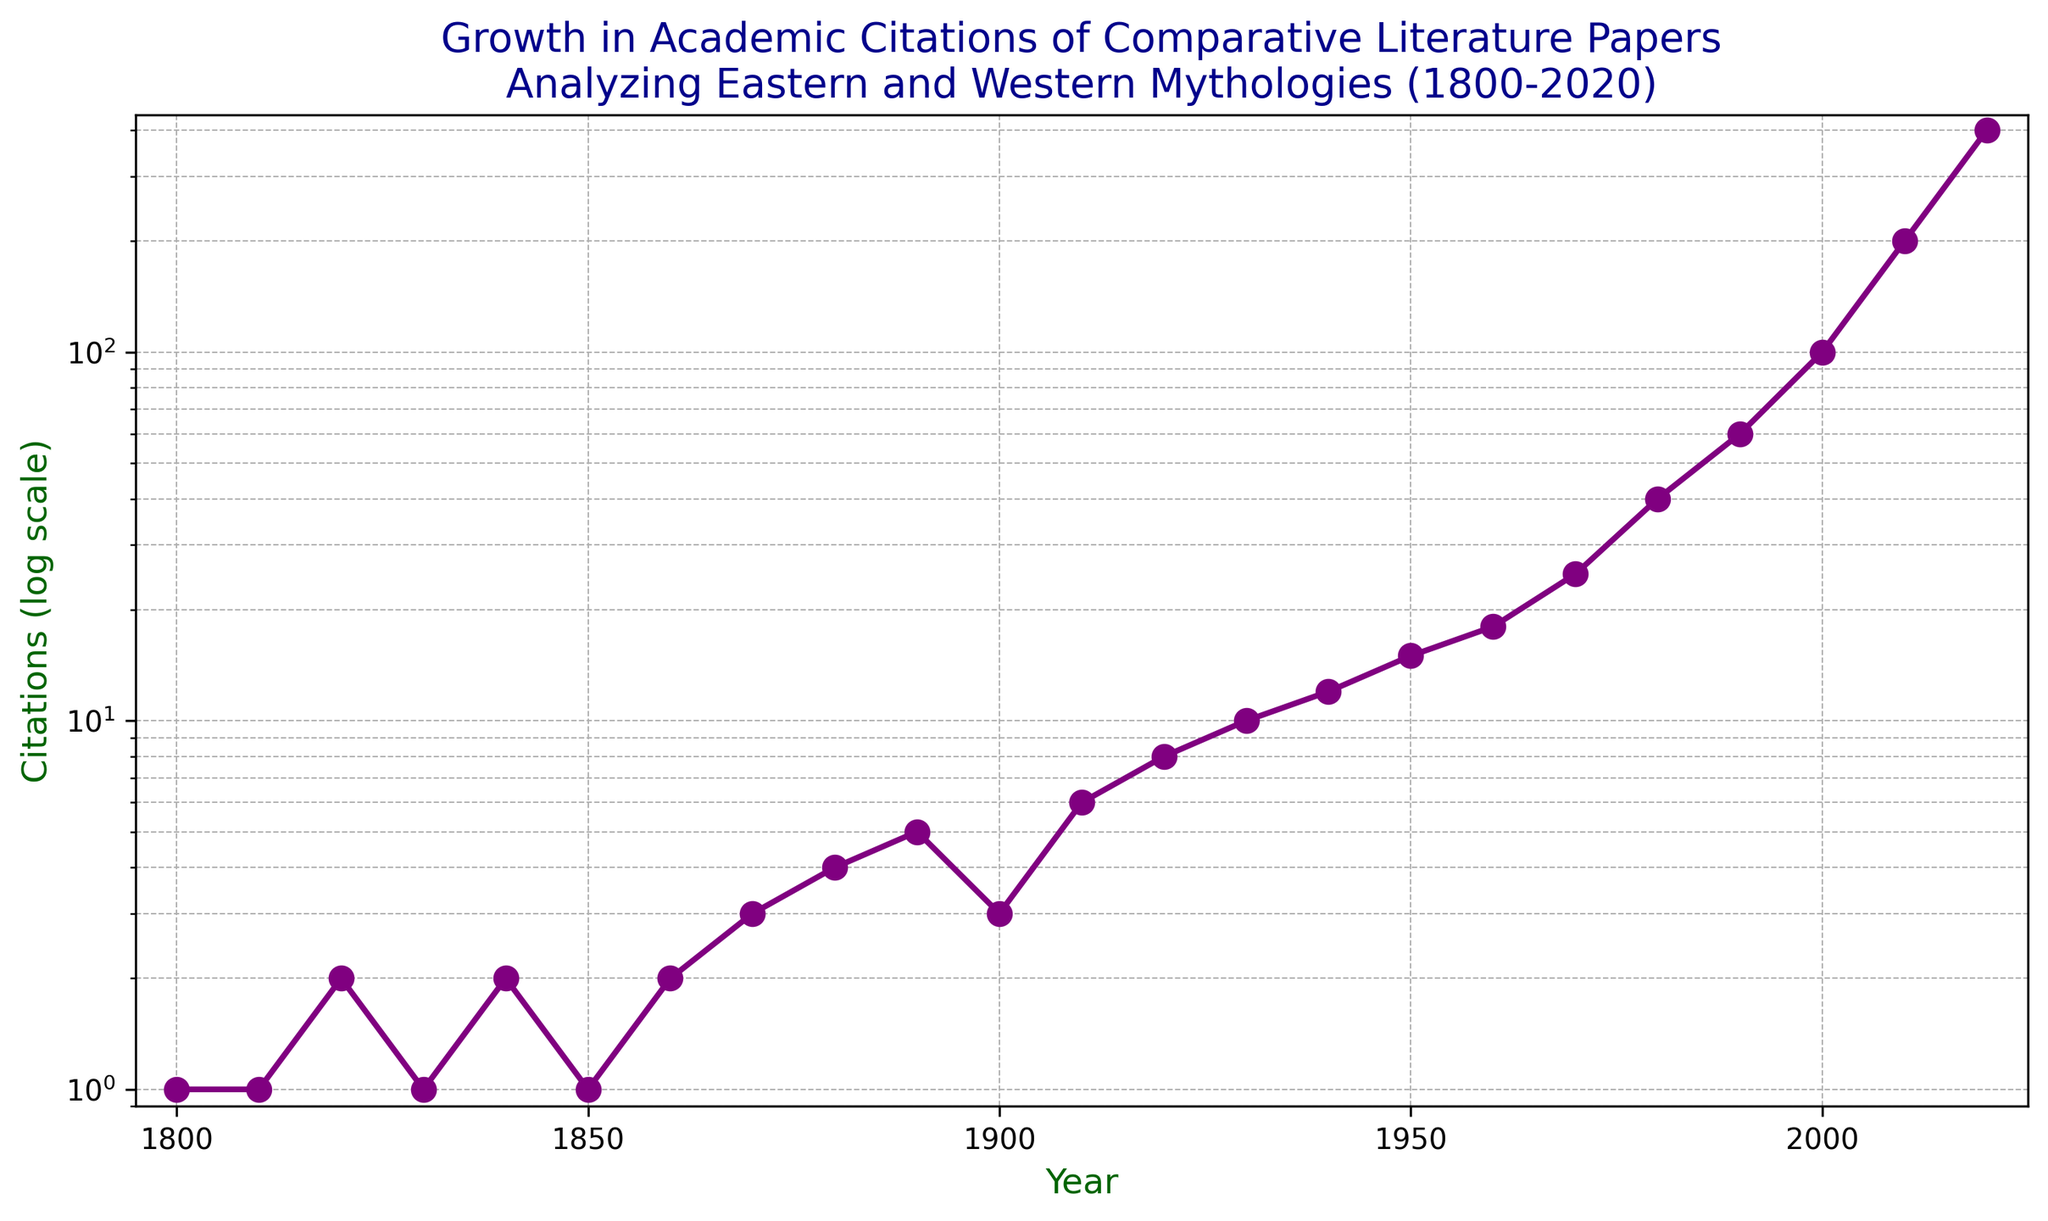What is the overall trend in the number of citations from 1800 to 2020? The citations exhibit a clear exponential growth trend. Starting with low citation counts in the 1800s, the numbers steadily increase over time, particularly accelerating after the 1970s. This exponential pattern is evidenced by the rapid rise from 100 citations in 2000 to 400 citations by 2020.
Answer: Exponential growth In which decade did the citations first reach double digits? By reviewing the data points on the chart, we see that citations first reached double digits in the 1930s, where the figure is indicated to be 10.
Answer: 1930s How many more citations were there in 2020 compared to 1970? Subtract the number of citations in 1970 from those in 2020: 400 - 25 = 375.
Answer: 375 How many times did the number of citations increase from 1900 to 2000? Compare the values for 1900 and 2000. The value in 1900 is 3 and in 2000 is 100. Divide 100 by 3 to find the increase factor: 100 / 3 ≈ 33.33 times.
Answer: ~33 times Which period had the most rapid increase in citations: 1900 to 1950 or 1950 to 2000? Calculate the increases for both periods: 1900 to 1950 increased from 3 to 15 (15 - 3 = 12), and 1950 to 2000 increased from 15 to 100 (100 - 15 = 85). Comparing the increases, the rapid increase occurred from 1950 to 2000.
Answer: 1950 to 2000 Are there any periods where the number of citations decreased or remained constant? Observing the data for any dips or plateaus, particularly between 1800-1890 and 1900-1910 do not show any clear decreases or prolonged constancy, indicating a generally consistent growth.
Answer: No In what year did the number of citations double from one decade to the next? Look for points on the graph where the values double. From 1980 to 1990, citations doubled from 40 to 60, but more accurately, from 2000 (100 citations) to 2010 (200 citations), the values precisely doubled.
Answer: 2000 to 2010 How does the growth rate from 2000 to 2020 compare to the growth rate from 1980 to 2000? Calculate the growth rates: From 1980 (40) to 2000 (100), it increased by a factor of 2.5 (100 / 40 = 2.5). From 2000 (100) to 2020 (400), it increased by a factor of 4 (400 / 100 = 4). Comparing these, the citation growth rate was higher from 2000 to 2020.
Answer: Higher from 2000 to 2020 What color is used to represent the data points on the plot? The visual attributes of the chart indicate that the data points (markers) are plotted in purple.
Answer: Purple 